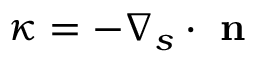Convert formula to latex. <formula><loc_0><loc_0><loc_500><loc_500>\kappa = - \nabla _ { s } \cdot n</formula> 